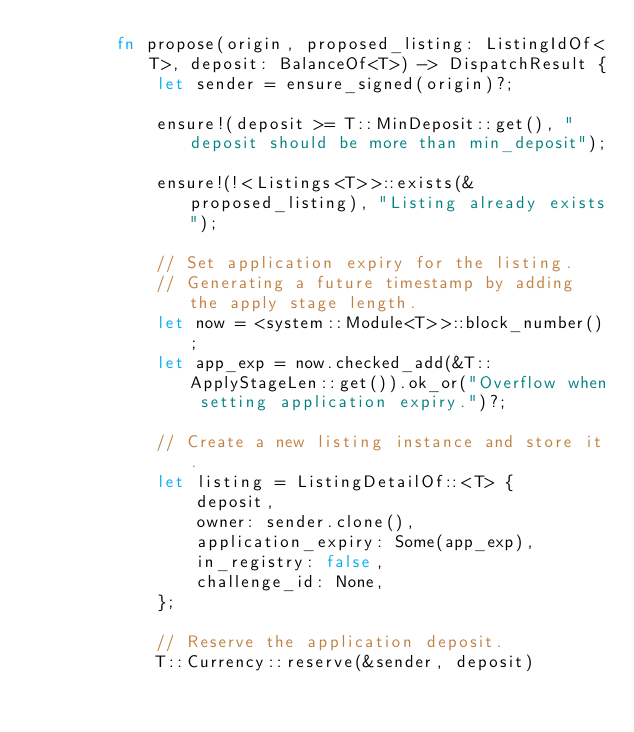Convert code to text. <code><loc_0><loc_0><loc_500><loc_500><_Rust_>		fn propose(origin, proposed_listing: ListingIdOf<T>, deposit: BalanceOf<T>) -> DispatchResult {
			let sender = ensure_signed(origin)?;

			ensure!(deposit >= T::MinDeposit::get(), "deposit should be more than min_deposit");

			ensure!(!<Listings<T>>::exists(&proposed_listing), "Listing already exists");

			// Set application expiry for the listing.
			// Generating a future timestamp by adding the apply stage length.
			let now = <system::Module<T>>::block_number();
			let app_exp = now.checked_add(&T::ApplyStageLen::get()).ok_or("Overflow when setting application expiry.")?;

			// Create a new listing instance and store it.
			let listing = ListingDetailOf::<T> {
				deposit,
				owner: sender.clone(),
				application_expiry: Some(app_exp),
				in_registry: false,
				challenge_id: None,
			};

			// Reserve the application deposit.
			T::Currency::reserve(&sender, deposit)</code> 